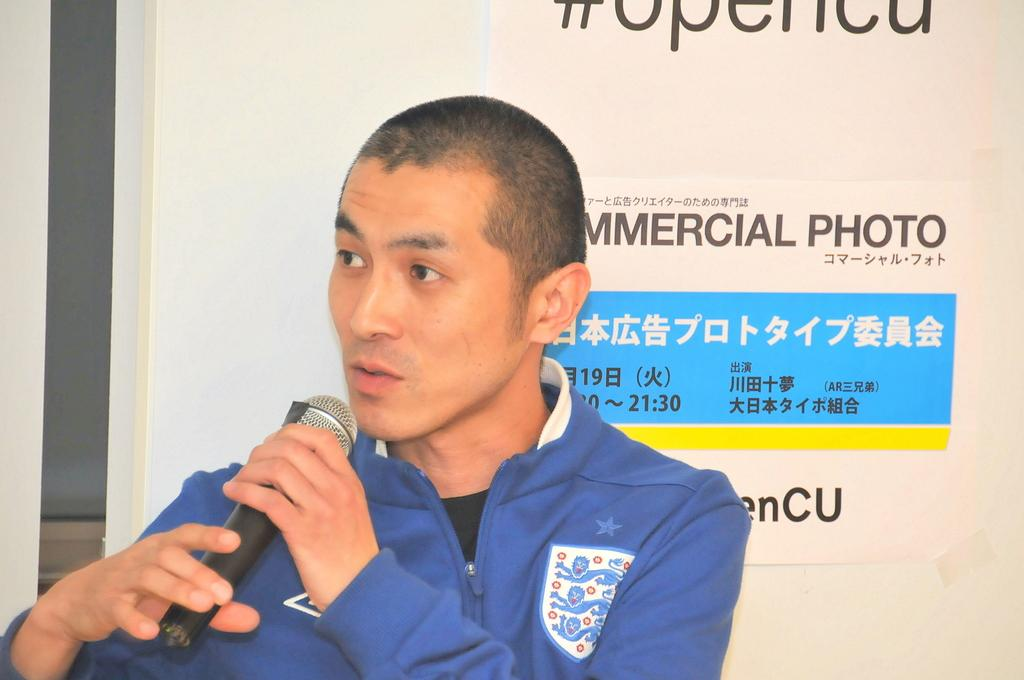Who is the main subject in the image? There is a man in the image. What is the man holding in the image? The man is holding a microphone. What is the man wearing in the image? The man is wearing a blue jacket. Can you describe what is written on the back of the jacket? Unfortunately, the facts provided do not specify what is written on the back of the jacket. What type of furniture is visible in the image? There is no furniture visible in the image; it features a man holding a microphone and wearing a blue jacket. What type of bell can be heard ringing in the image? There is no bell present in the image, and therefore no sound can be heard. 